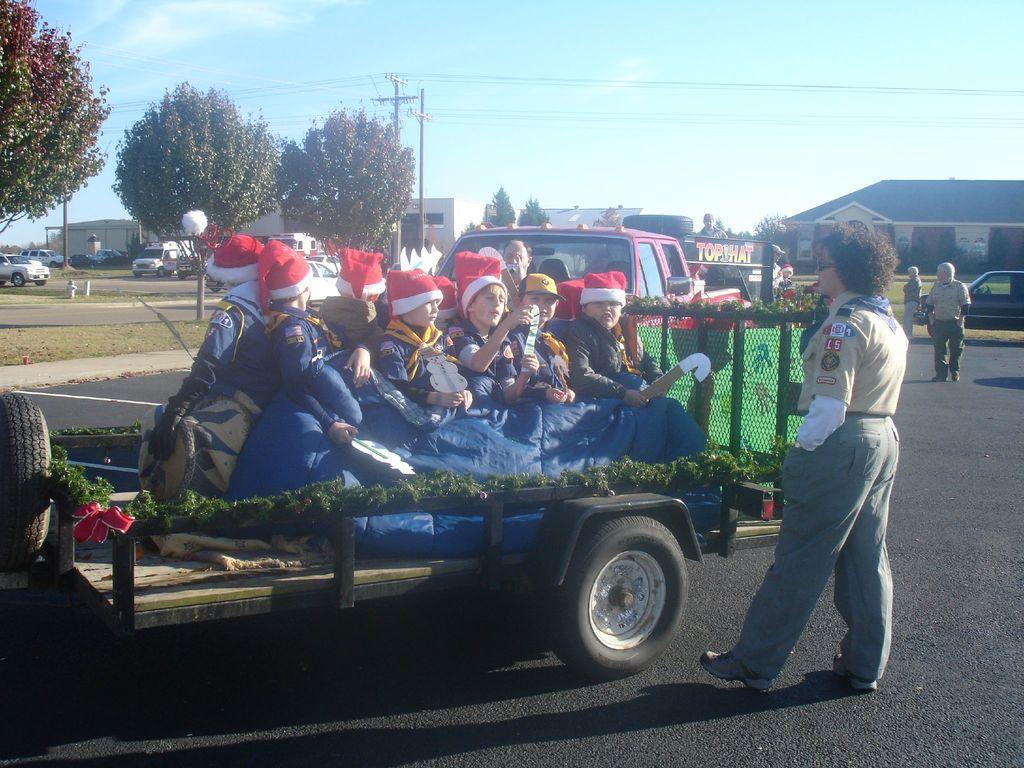Could you give a brief overview of what you see in this image? This picture is clicked outside the city. In this picture, we see children are sitting on the vehicle. They are wearing the red color caps. The woman on the right side is standing. Behind the vehicle, we see a red color vehicle. On the right side, we see the people are standing and we see a black car. On the left side, we see the cars are moving on the road. There are trees, poles, buildings, electric poles in the background. At the top, we see the sky. 